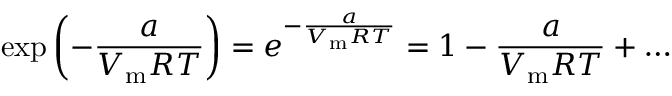Convert formula to latex. <formula><loc_0><loc_0><loc_500><loc_500>\exp \left ( - { \frac { a } { V _ { m } R T } } \right ) = e ^ { - { \frac { a } { V _ { m } R T } } } = 1 - { \frac { a } { V _ { m } R T } } + \dots</formula> 